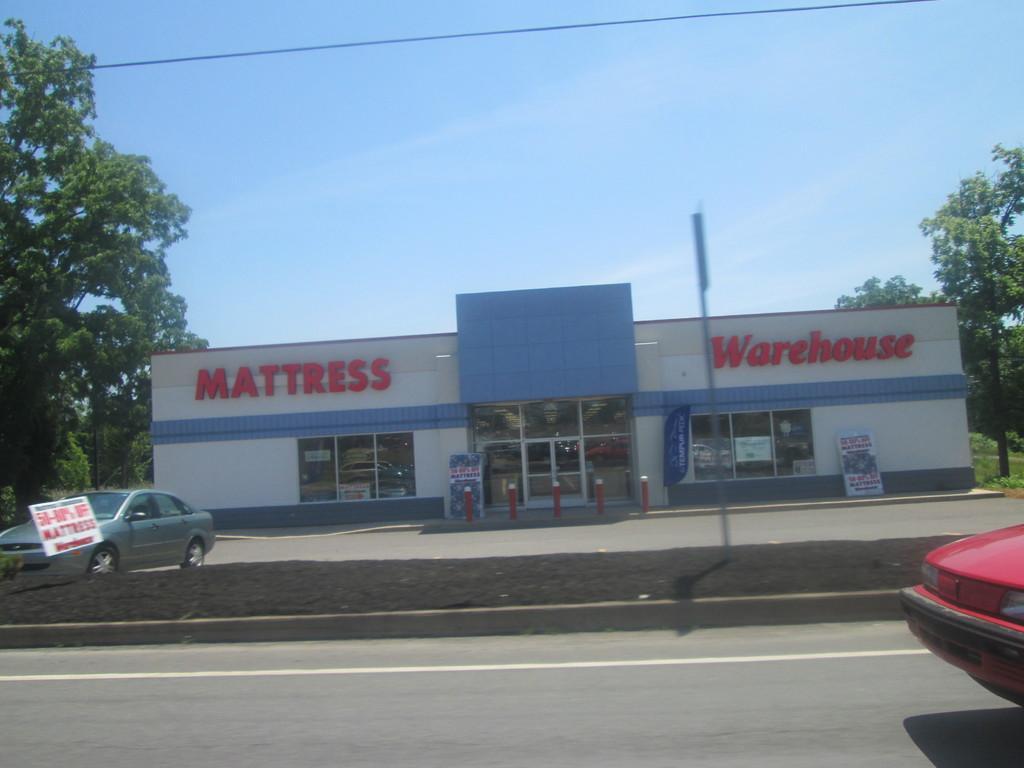In one or two sentences, can you explain what this image depicts? In this picture we can see vehicles on the roads, poles, boards, store, wire and trees. In the background of the image we can see the sky. 